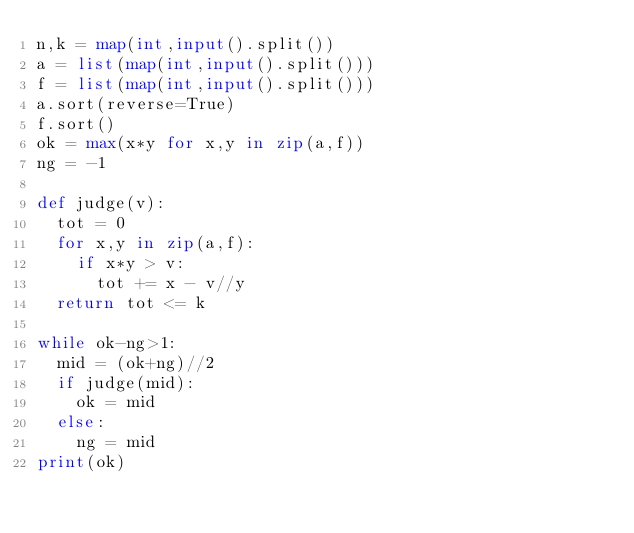Convert code to text. <code><loc_0><loc_0><loc_500><loc_500><_Python_>n,k = map(int,input().split())
a = list(map(int,input().split()))
f = list(map(int,input().split()))
a.sort(reverse=True)
f.sort()
ok = max(x*y for x,y in zip(a,f))
ng = -1

def judge(v):
  tot = 0
  for x,y in zip(a,f):
    if x*y > v:
      tot += x - v//y
  return tot <= k

while ok-ng>1:
  mid = (ok+ng)//2
  if judge(mid):
    ok = mid
  else:
    ng = mid
print(ok)</code> 